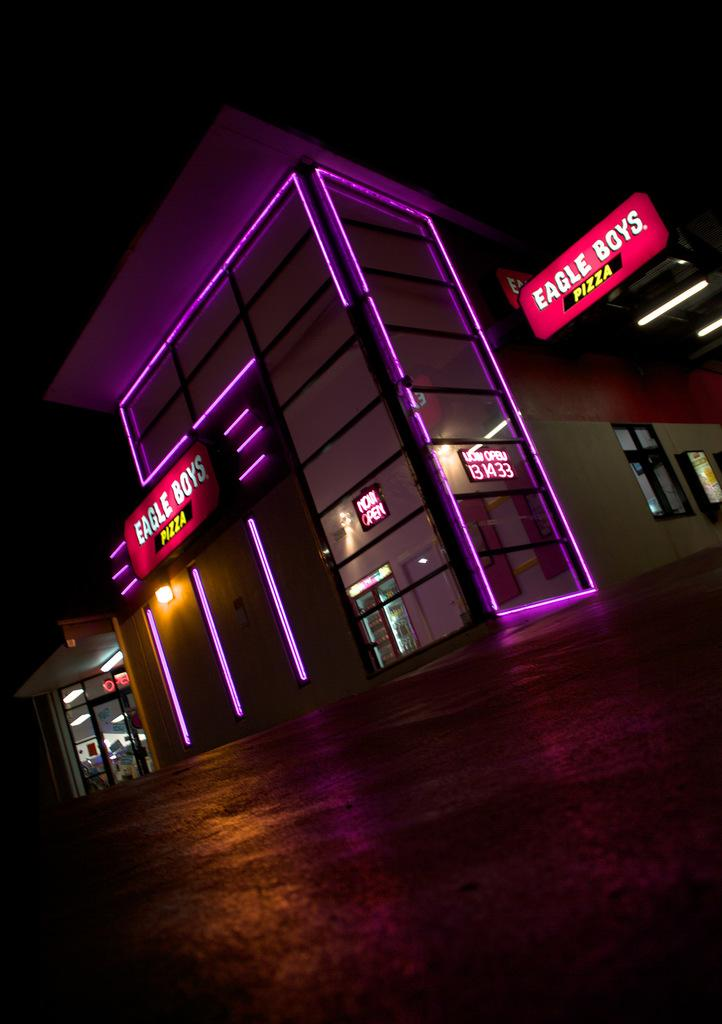What is the main feature of the image? There is a road in the image. What can be seen in the distance behind the road? There are buildings in the background of the image. What is special about the buildings? The buildings have lights and hoardings attached to their walls. How would you describe the overall appearance of the background in the image? The background of the image is dark in color. What type of toothbrush is hanging from the hoarding on the building in the image? There is no toothbrush present in the image. What scientific experiment is being conducted on the road in the image? There is no scientific experiment being conducted in the image; it simply shows a road and buildings in the background. 